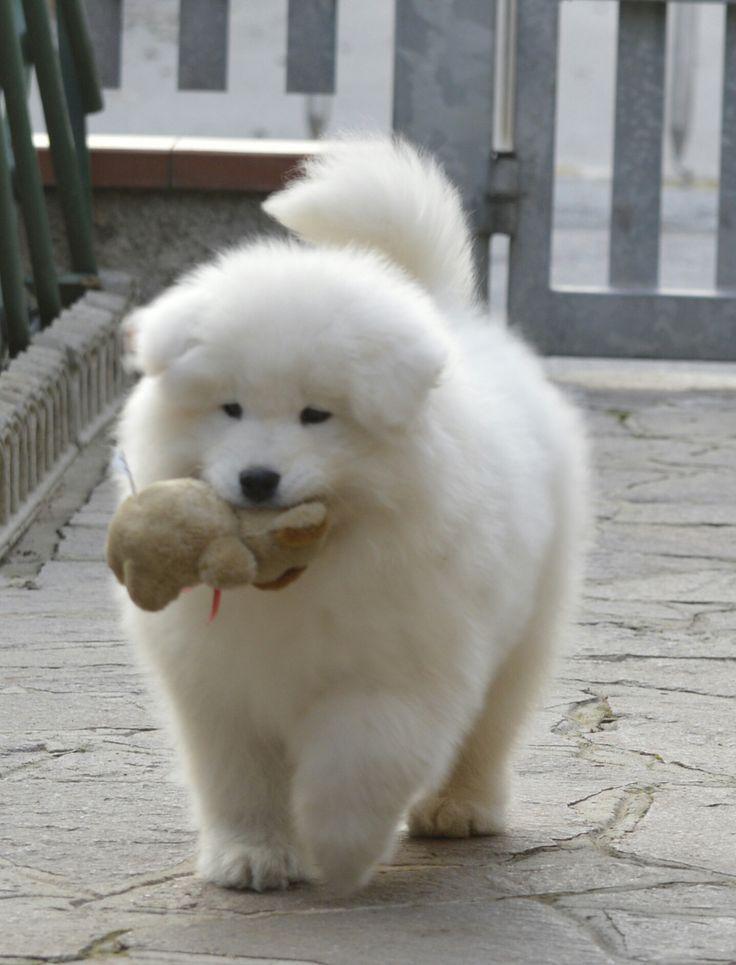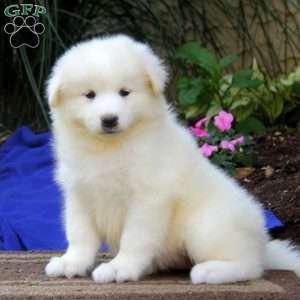The first image is the image on the left, the second image is the image on the right. Examine the images to the left and right. Is the description "At least one image has an adult dog in it." accurate? Answer yes or no. No. 